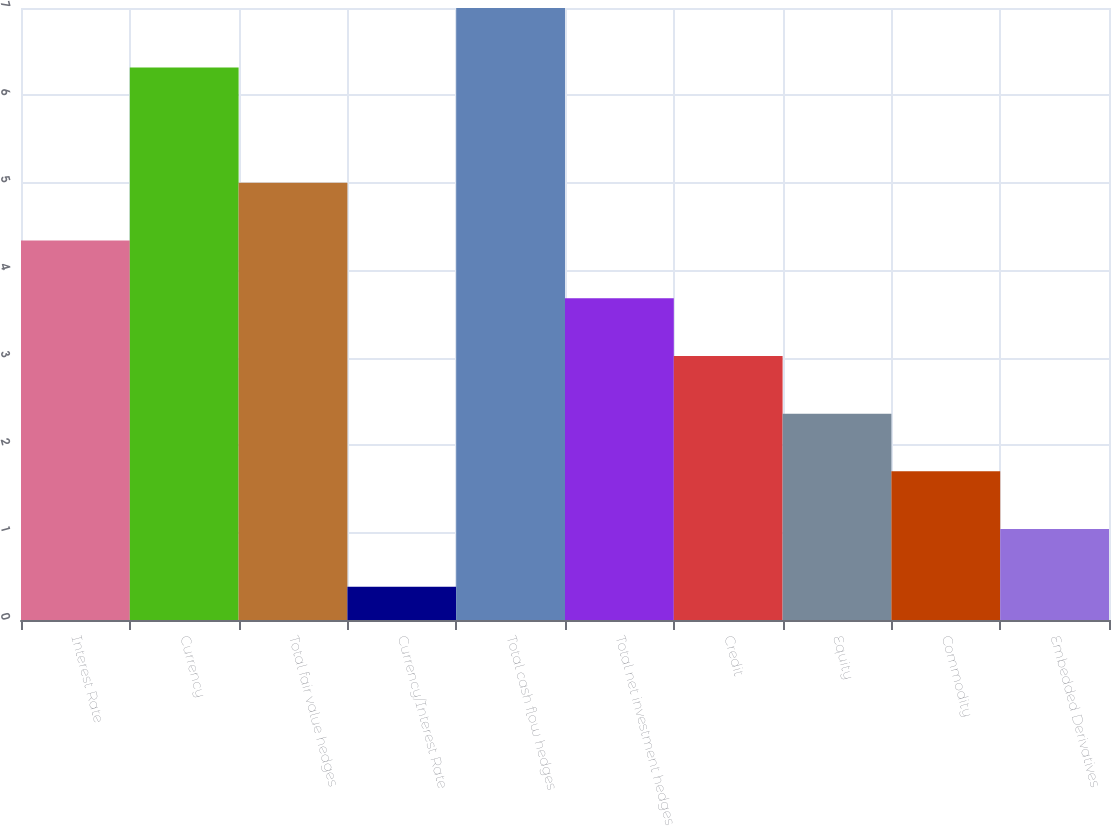<chart> <loc_0><loc_0><loc_500><loc_500><bar_chart><fcel>Interest Rate<fcel>Currency<fcel>Total fair value hedges<fcel>Currency/Interest Rate<fcel>Total cash flow hedges<fcel>Total net investment hedges<fcel>Credit<fcel>Equity<fcel>Commodity<fcel>Embedded Derivatives<nl><fcel>4.34<fcel>6.32<fcel>5<fcel>0.38<fcel>7<fcel>3.68<fcel>3.02<fcel>2.36<fcel>1.7<fcel>1.04<nl></chart> 